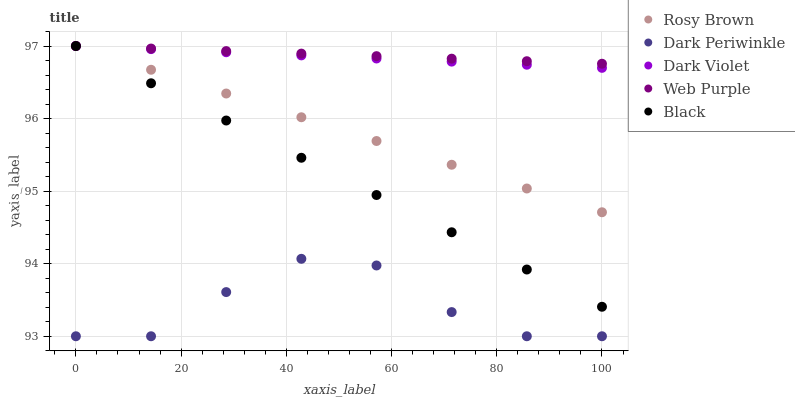Does Dark Periwinkle have the minimum area under the curve?
Answer yes or no. Yes. Does Web Purple have the maximum area under the curve?
Answer yes or no. Yes. Does Rosy Brown have the minimum area under the curve?
Answer yes or no. No. Does Rosy Brown have the maximum area under the curve?
Answer yes or no. No. Is Web Purple the smoothest?
Answer yes or no. Yes. Is Dark Periwinkle the roughest?
Answer yes or no. Yes. Is Rosy Brown the smoothest?
Answer yes or no. No. Is Rosy Brown the roughest?
Answer yes or no. No. Does Dark Periwinkle have the lowest value?
Answer yes or no. Yes. Does Rosy Brown have the lowest value?
Answer yes or no. No. Does Dark Violet have the highest value?
Answer yes or no. Yes. Does Dark Periwinkle have the highest value?
Answer yes or no. No. Is Dark Periwinkle less than Rosy Brown?
Answer yes or no. Yes. Is Black greater than Dark Periwinkle?
Answer yes or no. Yes. Does Web Purple intersect Dark Violet?
Answer yes or no. Yes. Is Web Purple less than Dark Violet?
Answer yes or no. No. Is Web Purple greater than Dark Violet?
Answer yes or no. No. Does Dark Periwinkle intersect Rosy Brown?
Answer yes or no. No. 